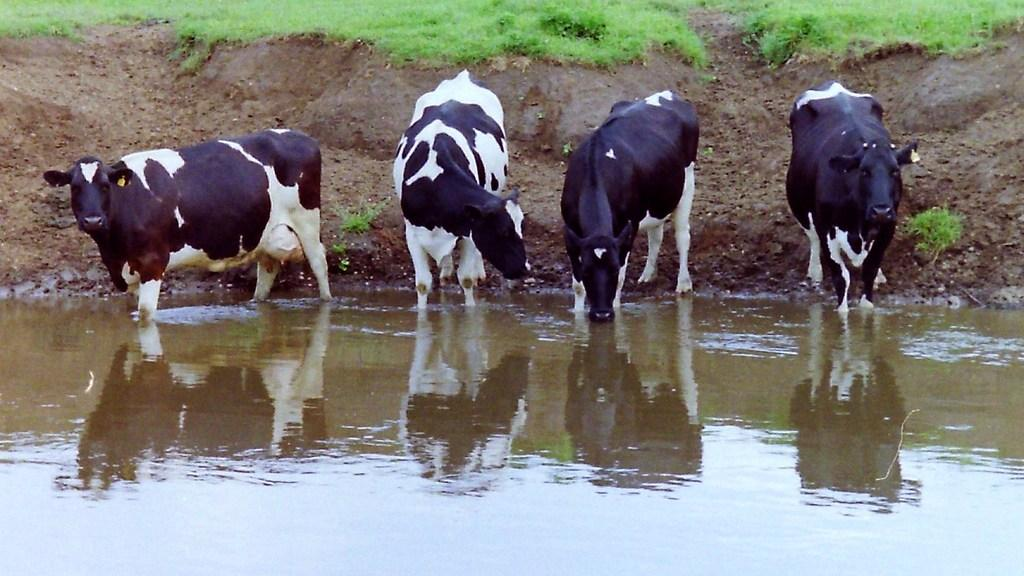How many animals are present in the image? There are four animals in the image. What color combination is used for the animals? The animals are in black and white color combination. Where are the animals located in relation to the water? The animals are standing near the water. Which animal is performing an action in the image? One of the animals is drinking water. What type of vegetation can be seen in the background of the image? There is grass in the background of the image. What type of marble is being used to create the amusement park in the image? There is no marble or amusement park present in the image; it features four animals near the water. Who is the representative of the animals in the image? There is no need for a representative, as the animals are not participating in any formal event or activity in the image. 